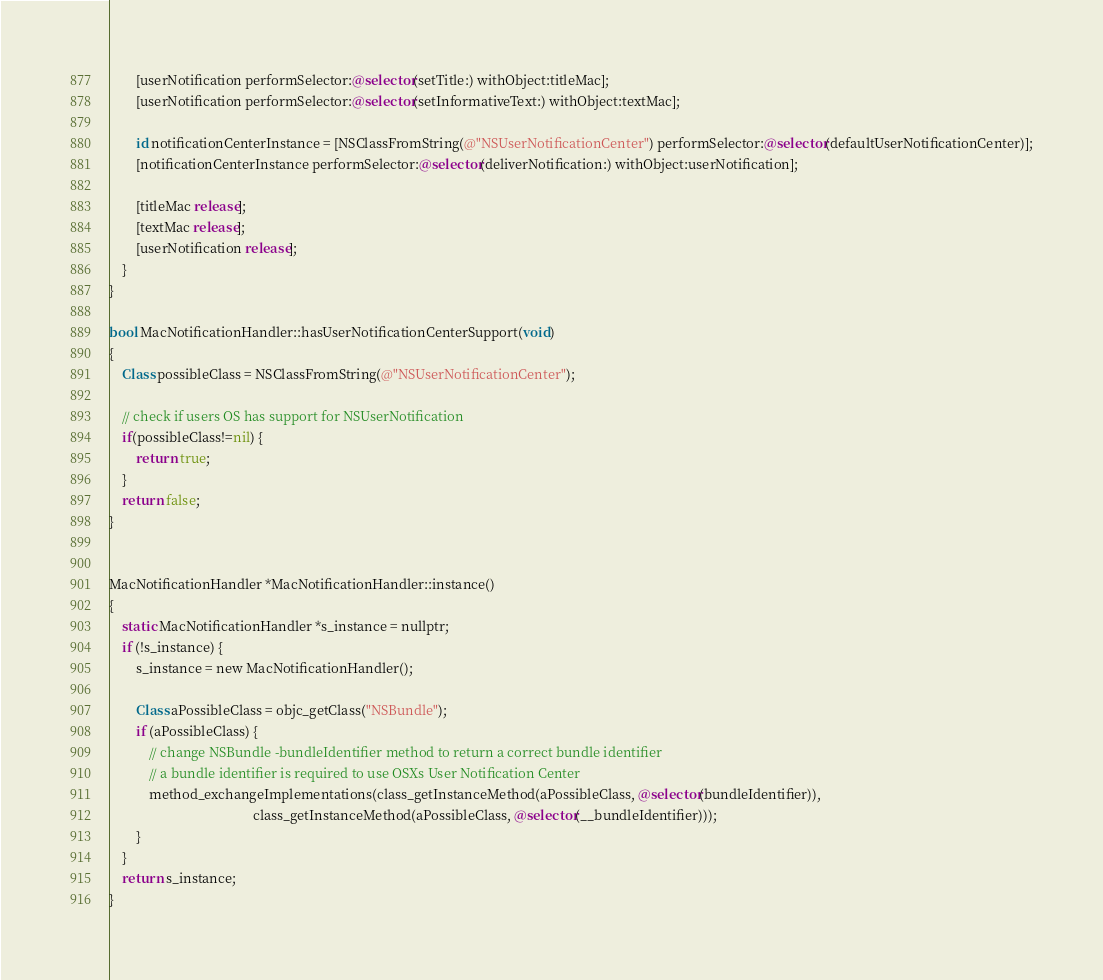Convert code to text. <code><loc_0><loc_0><loc_500><loc_500><_ObjectiveC_>        [userNotification performSelector:@selector(setTitle:) withObject:titleMac];
        [userNotification performSelector:@selector(setInformativeText:) withObject:textMac];

        id notificationCenterInstance = [NSClassFromString(@"NSUserNotificationCenter") performSelector:@selector(defaultUserNotificationCenter)];
        [notificationCenterInstance performSelector:@selector(deliverNotification:) withObject:userNotification];

        [titleMac release];
        [textMac release];
        [userNotification release];
    }
}

bool MacNotificationHandler::hasUserNotificationCenterSupport(void)
{
    Class possibleClass = NSClassFromString(@"NSUserNotificationCenter");

    // check if users OS has support for NSUserNotification
    if(possibleClass!=nil) {
        return true;
    }
    return false;
}


MacNotificationHandler *MacNotificationHandler::instance()
{
    static MacNotificationHandler *s_instance = nullptr;
    if (!s_instance) {
        s_instance = new MacNotificationHandler();
        
        Class aPossibleClass = objc_getClass("NSBundle");
        if (aPossibleClass) {
            // change NSBundle -bundleIdentifier method to return a correct bundle identifier
            // a bundle identifier is required to use OSXs User Notification Center
            method_exchangeImplementations(class_getInstanceMethod(aPossibleClass, @selector(bundleIdentifier)),
                                           class_getInstanceMethod(aPossibleClass, @selector(__bundleIdentifier)));
        }
    }
    return s_instance;
}
</code> 